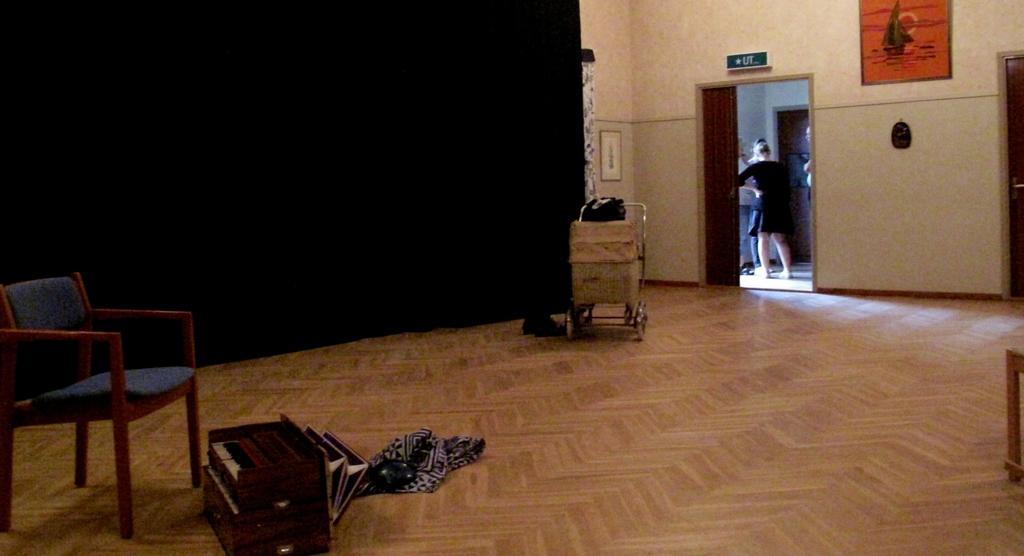In one or two sentences, can you explain what this image depicts? In this room we can able to see a luggage on cart, musical instrument, cloth and chair in blue color. A picture is on wall. Outside of the room a woman is standing and wore black dress. This wall is in black color. 